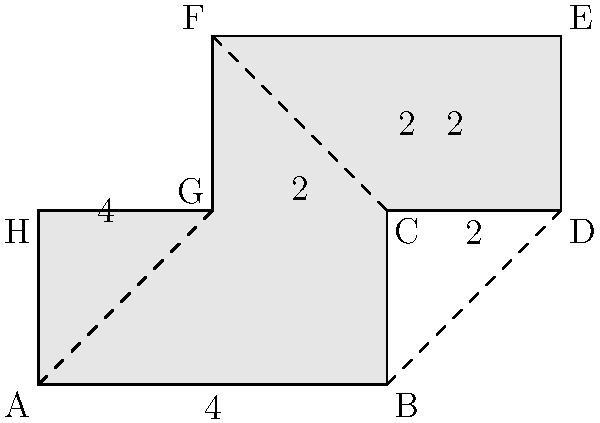As a journalist investigating gerrymandering, you're analyzing an irregularly shaped voting district. The district's shape is shown in the diagram, with dimensions in kilometers. Calculate the total area of this voting district to assess its compactness. To calculate the area of this irregular shape, we can break it down into rectangles and triangles:

1. Divide the shape into three rectangles (ABCH, CDEG, DEFG) and two triangles (BCG, DEF).

2. Calculate areas of rectangles:
   - Rectangle ABCH: $4 \times 2 = 8$ km²
   - Rectangle CDEG: $2 \times 2 = 4$ km²
   - Rectangle DEFG: $4 \times 2 = 8$ km²

3. Calculate areas of triangles:
   - Triangle BCG: $\frac{1}{2} \times 2 \times 2 = 2$ km²
   - Triangle DEF: $\frac{1}{2} \times 2 \times 2 = 2$ km²

4. Sum up all areas:
   $$ \text{Total Area} = 8 + 4 + 8 + 2 + 2 = 24 \text{ km}^2 $$

Therefore, the total area of the voting district is 24 square kilometers.
Answer: 24 km² 